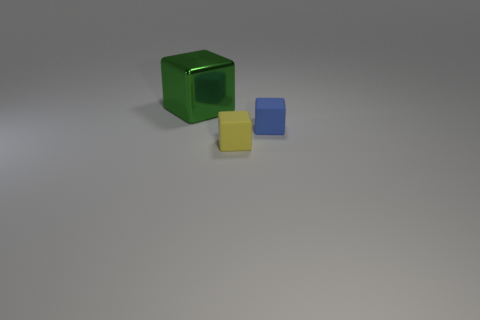Is there any other thing that is the same size as the shiny thing?
Offer a terse response. No. There is a cube that is in front of the metal cube and behind the small yellow rubber thing; what color is it?
Keep it short and to the point. Blue. Does the cube that is right of the yellow block have the same material as the block that is left of the yellow object?
Offer a very short reply. No. Are there more big metallic cubes behind the green shiny cube than tiny yellow cubes behind the small yellow block?
Provide a short and direct response. No. How many things are either small matte cubes or cubes in front of the large metallic thing?
Provide a succinct answer. 2. How many small objects are right of the tiny yellow thing?
Give a very brief answer. 1. What is the color of the other block that is the same material as the small yellow cube?
Offer a terse response. Blue. What number of shiny things are either blue blocks or green things?
Offer a very short reply. 1. Does the blue block have the same material as the large thing?
Offer a very short reply. No. What is the shape of the small object that is to the right of the yellow thing?
Ensure brevity in your answer.  Cube. 